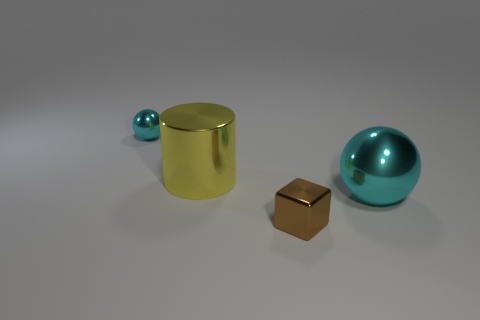Could you guess what time of day it is based on the lighting in the image? The lighting in the image is artificial and indirect, making it difficult to determine a specific time of day. The environment suggests an indoor setting with controlled lighting. 